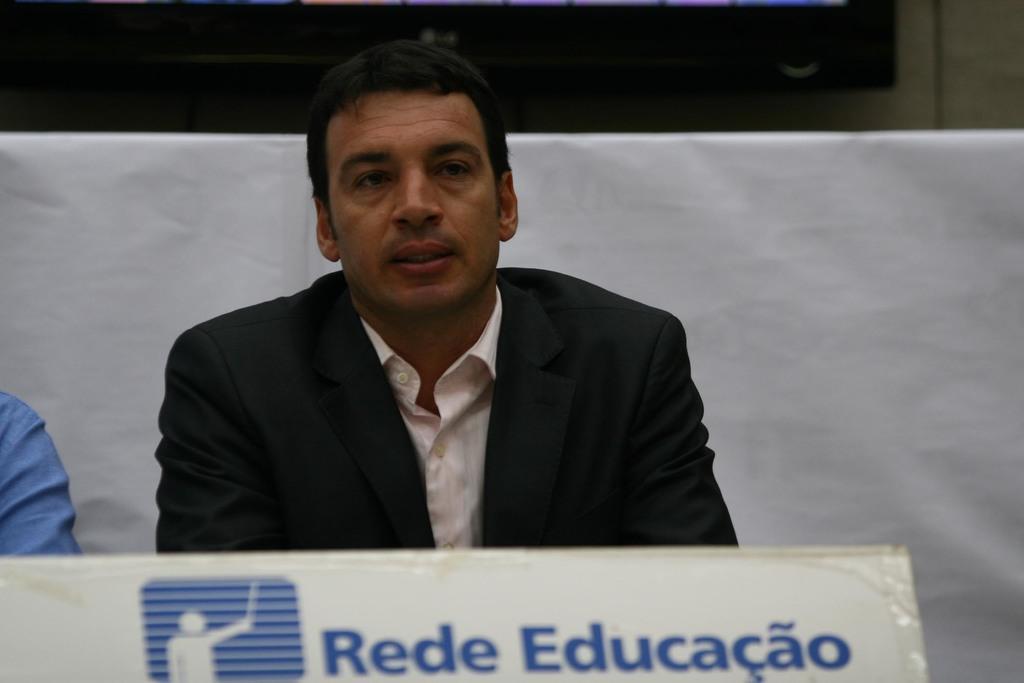How would you summarize this image in a sentence or two? In this image, in the middle, we can see a man wearing a black color coat is sitting on the chair. On the left side, we can also see hand of a person. In the background, we can see a white color cloth and black color. At the bottom, we can see a board, on which some text is written on it. 